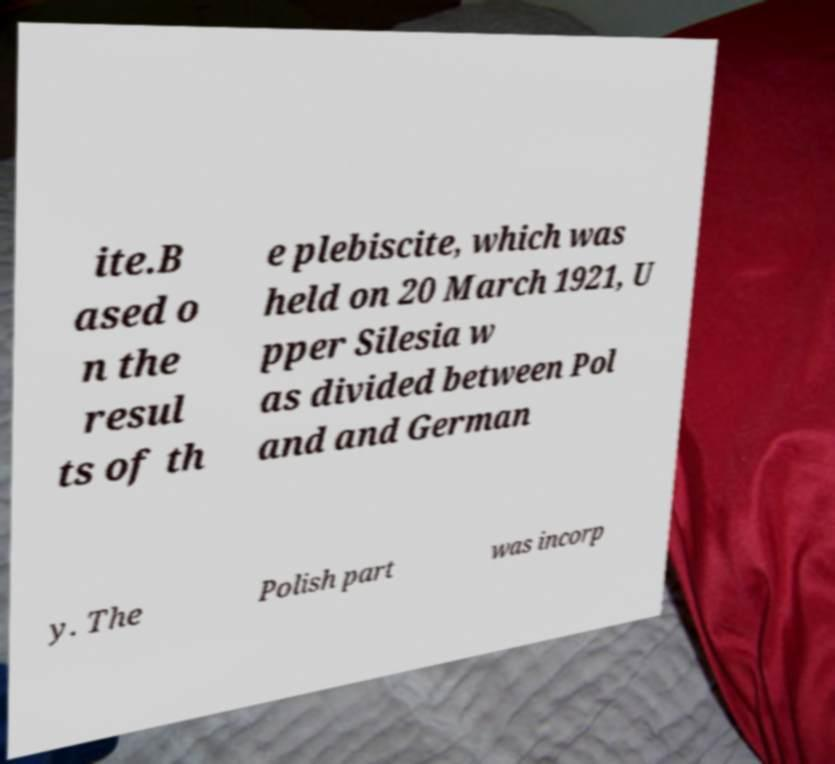Could you assist in decoding the text presented in this image and type it out clearly? ite.B ased o n the resul ts of th e plebiscite, which was held on 20 March 1921, U pper Silesia w as divided between Pol and and German y. The Polish part was incorp 